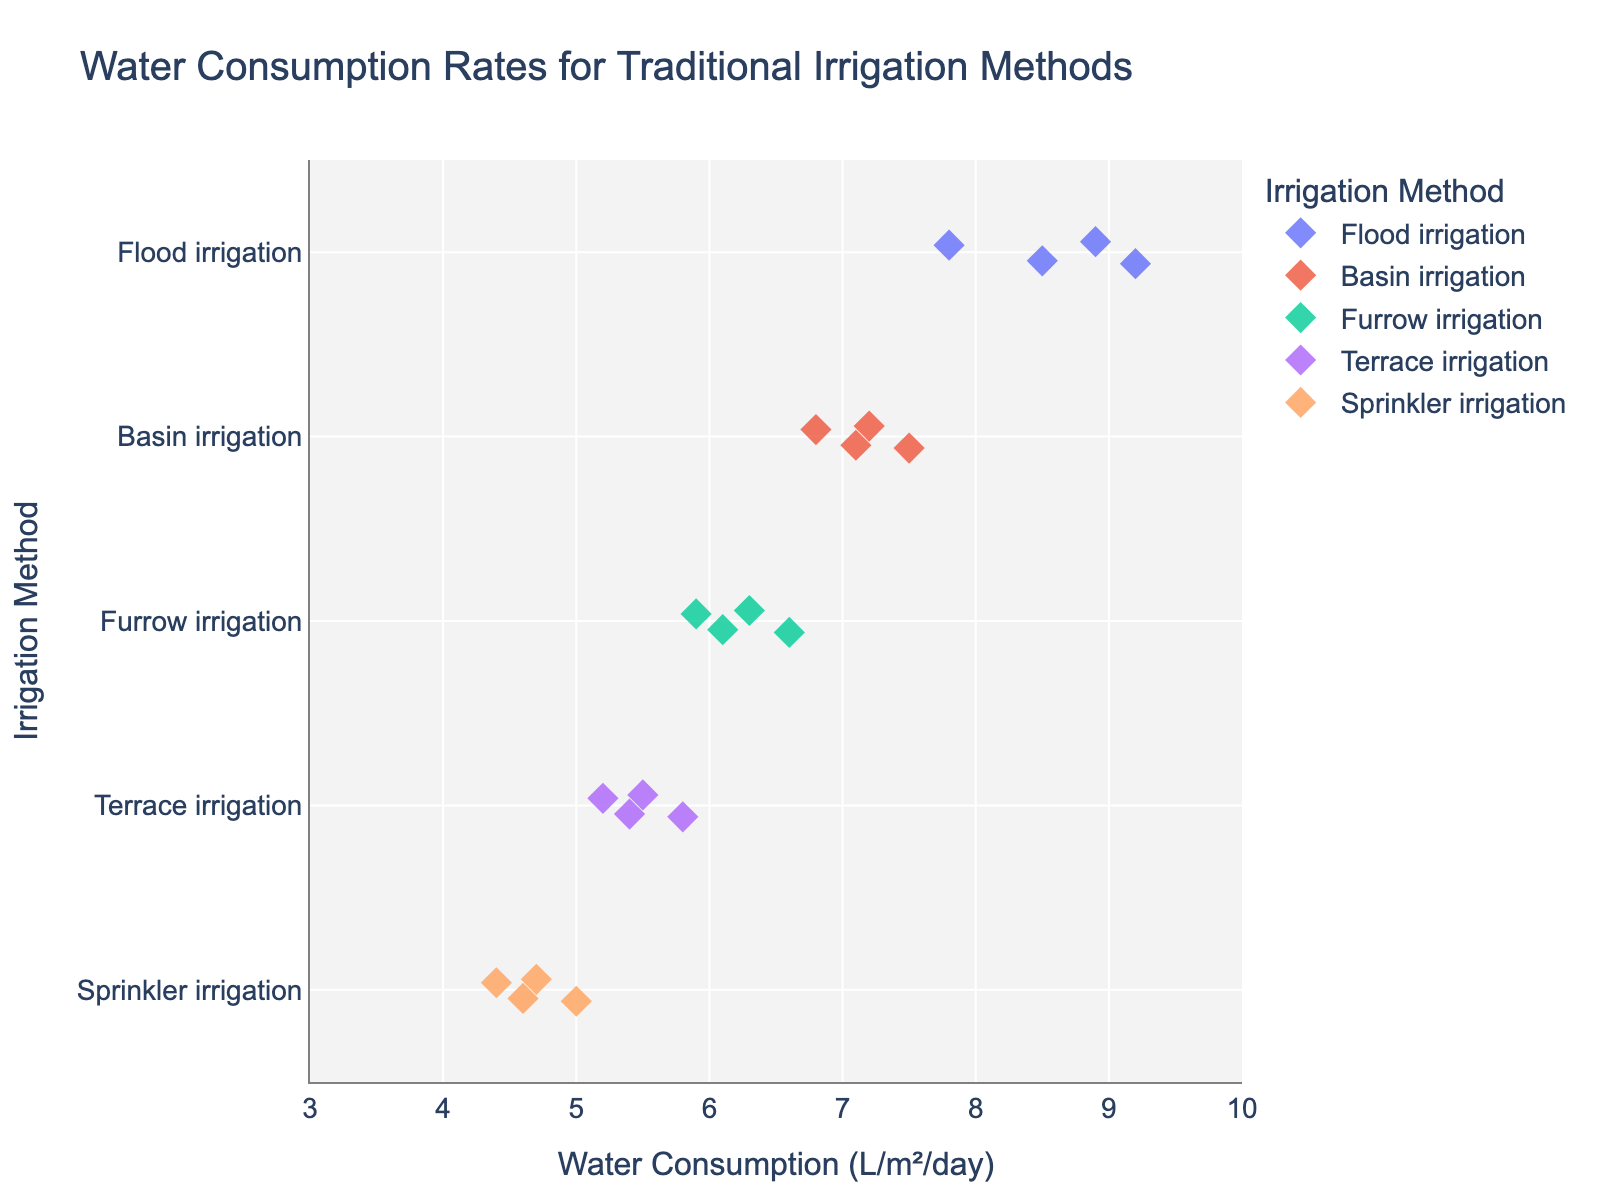What's the title of the figure? The title is written at the top of the figure, it states the main topic or subject of the data presented.
Answer: Water Consumption Rates for Traditional Irrigation Methods What are the different irrigation methods shown in the figure? The different irrigation methods are labeled on the y-axis of the figure.
Answer: Flood irrigation, Basin irrigation, Furrow irrigation, Terrace irrigation, Sprinkler irrigation What is the range of water consumption for Furrow irrigation? Look at the points along the 'Furrow irrigation' row and note the minimum and maximum values.
Answer: 5.9 to 6.6 liters per square meter per day Which irrigation method has the lowest overall water consumption values? Compare the water consumption ranges of all methods; the one with the lower range indicates the least water consumption.
Answer: Sprinkler irrigation What is the average water consumption for Flood irrigation? Add the water consumption values for Flood irrigation and divide by the number of values: (8.5 + 9.2 + 7.8 + 8.9) / 4.
Answer: 8.6 liters per square meter per day Between Basin and Terrace irrigation, which has a wider range of water consumption values? Calculate the range (maximum - minimum) for both methods and compare. Basin: 7.5 - 6.8 = 0.7; Terrace: 5.8 - 5.2 = 0.6.
Answer: Basin irrigation Which irrigation method shows the most consistent water consumption? Identify the method with the smallest difference between its highest and lowest values, indicating less variability.
Answer: Terrace irrigation What's the median water consumption value for Sprinkler irrigation? Arrange the values (4.7, 4.4, 5.0, 4.6) in ascending order and find the median value: (4.4, 4.6, 4.7, 5.0).
Answer: 4.65 liters per square meter per day How many data points are there for each irrigation method? Count the number of points plotted for each irrigation method along the y-axis.
Answer: 4 points for each method 